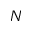<formula> <loc_0><loc_0><loc_500><loc_500>N</formula> 